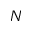<formula> <loc_0><loc_0><loc_500><loc_500>N</formula> 